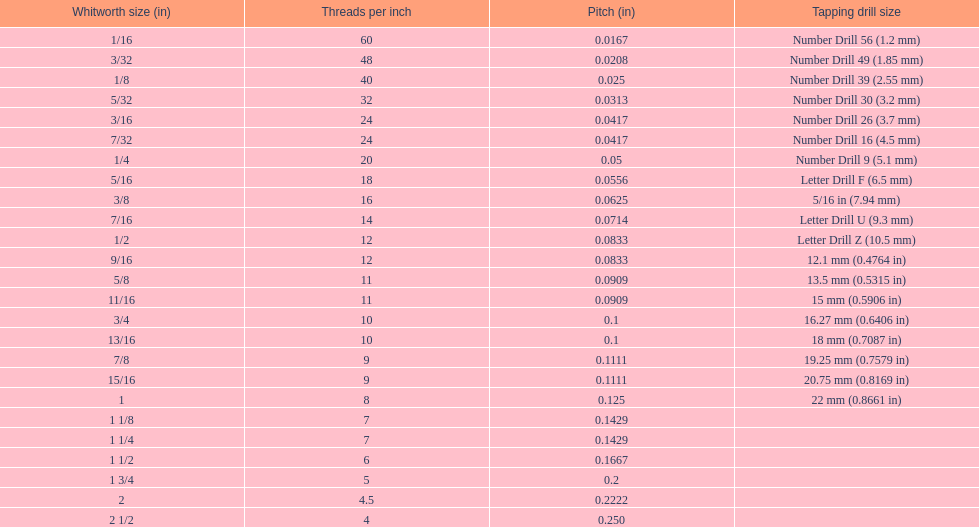What is the core diameter of the first 1/8 whitworth size (in)? 0.0930. 